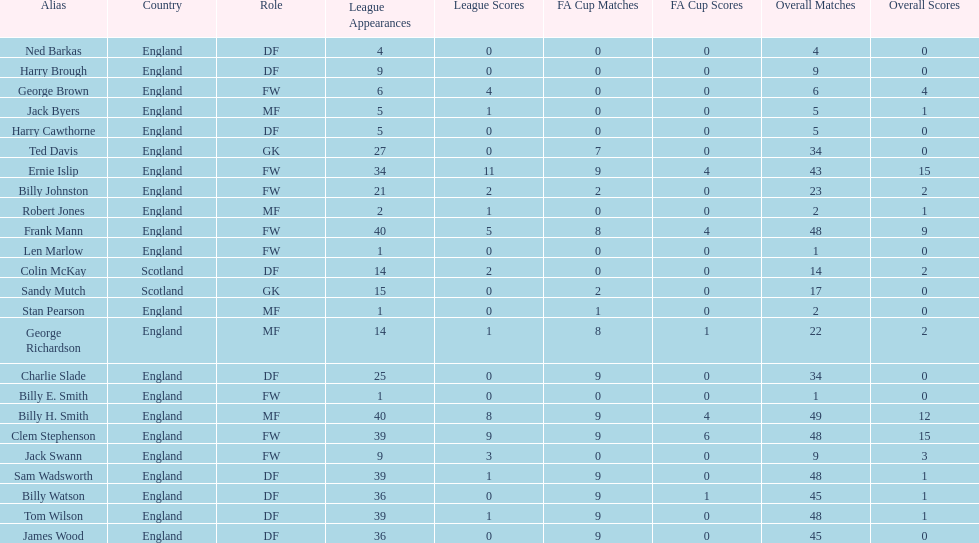Name the nation with the most appearances. England. 